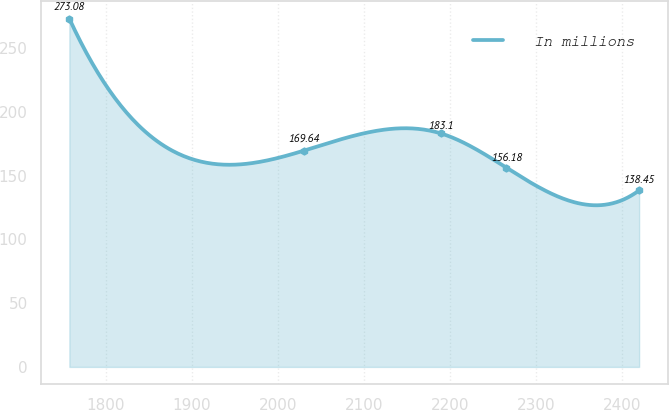Convert chart. <chart><loc_0><loc_0><loc_500><loc_500><line_chart><ecel><fcel>In millions<nl><fcel>1757.49<fcel>273.08<nl><fcel>2030.45<fcel>169.64<nl><fcel>2189.63<fcel>183.1<nl><fcel>2265.9<fcel>156.18<nl><fcel>2420.22<fcel>138.45<nl></chart> 